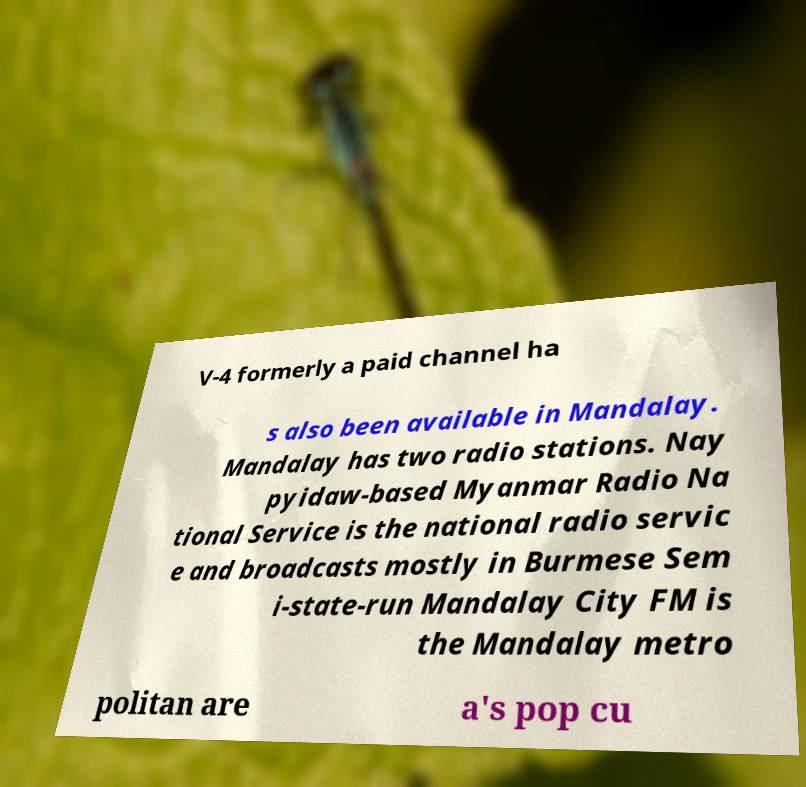Please read and relay the text visible in this image. What does it say? V-4 formerly a paid channel ha s also been available in Mandalay. Mandalay has two radio stations. Nay pyidaw-based Myanmar Radio Na tional Service is the national radio servic e and broadcasts mostly in Burmese Sem i-state-run Mandalay City FM is the Mandalay metro politan are a's pop cu 